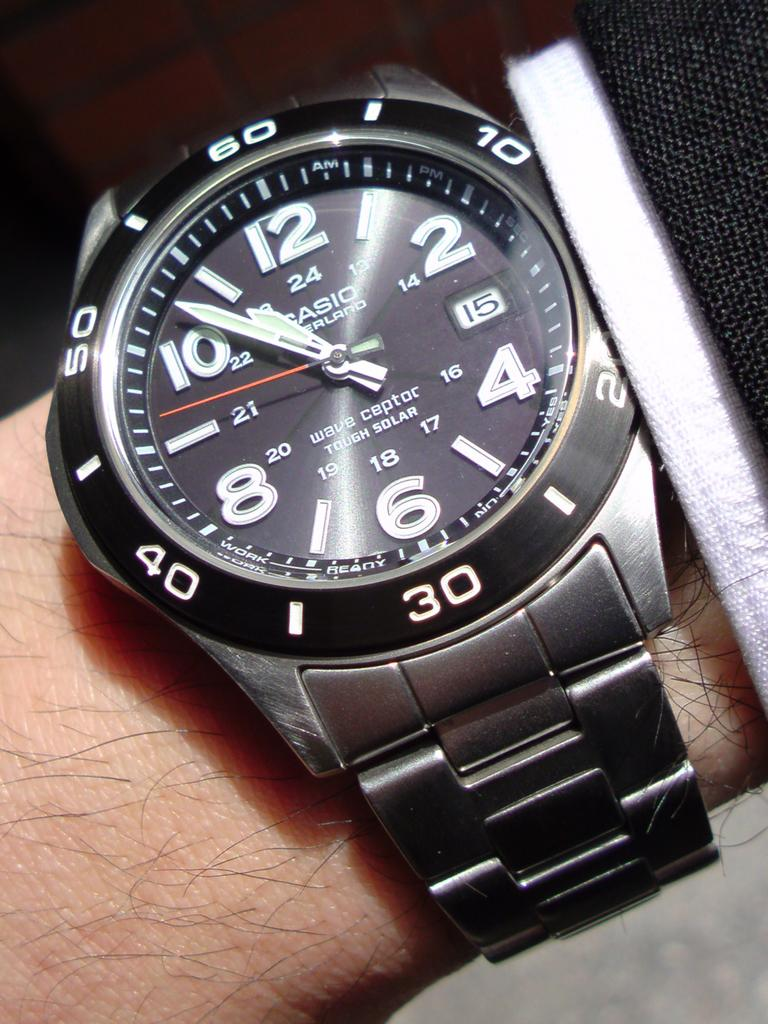Provide a one-sentence caption for the provided image. A Casio watch shows that the time is now 10:53. 